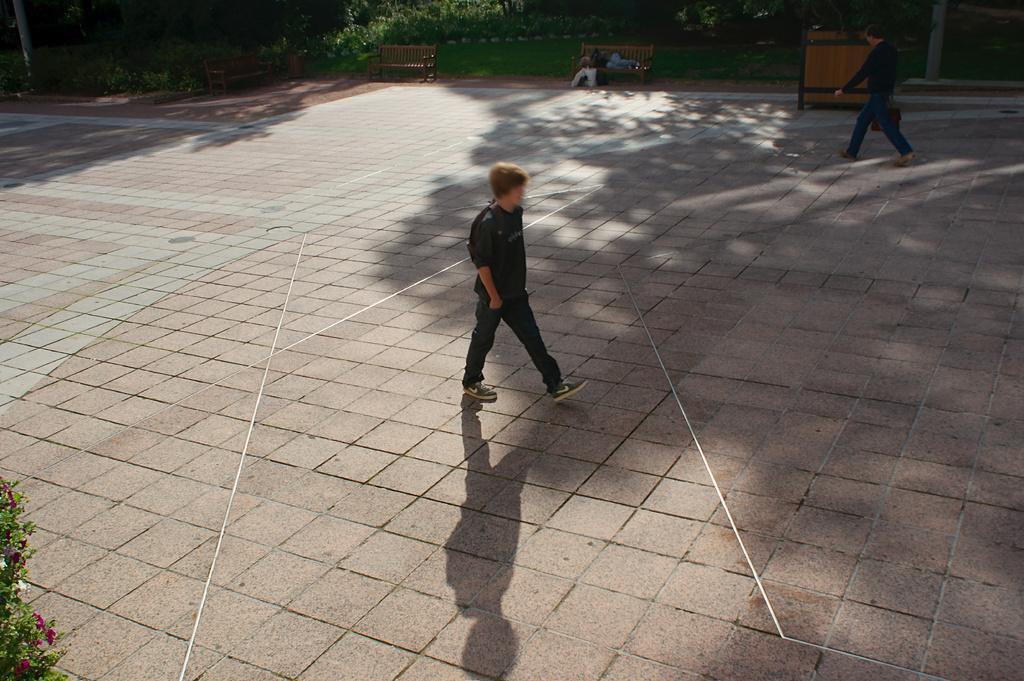In one or two sentences, can you explain what this image depicts? In this image, we can see two people walking on the floor, we can see two benches, we can see some plants. 